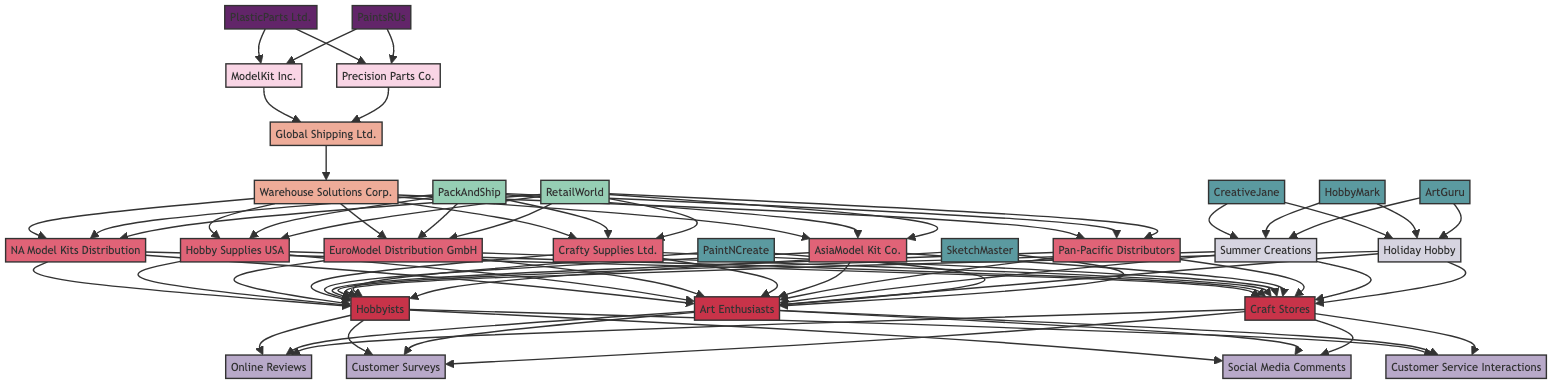What are the two manufacturers listed in the diagram? The diagram shows two manufacturers: ModelKit Inc. and Precision Parts Co.
Answer: ModelKit Inc., Precision Parts Co How many regional distributors are there in total? There are six regional distributors listed: NA Model Kits Distribution, Hobby Supplies USA, EuroModel Distribution GmbH, Crafty Supplies Ltd., AsiaModel Kit Co., and Pan-Pacific Distributors.
Answer: 6 Which influencer has the most followers? Upon reviewing the influencer section, HobbyMark has the highest follower count at 200,000.
Answer: HobbyMark What is the relationship between the influencers and the marketing campaigns? Each influencer is linked to at least one marketing campaign, with CreativeJane, HobbyMark, and ArtGuru connected to the campaigns "Summer Creations" and "Holiday Hobby".
Answer: Influencer-campaign connection How many feedback sources are identified in the customer feedback ecosystem? The diagram shows four feedback sources: Online Reviews, Customer Surveys, Social Media Comments, and Customer Service Interactions.
Answer: 4 Which supplier has high dependency? In the supplier relationships, PlasticParts Ltd. is indicated to have high dependency, while PaintsRUs has medium dependency.
Answer: PlasticParts Ltd Which distributor serves the North American region? The diagram highlights two distributors for North America: NA Model Kits Distribution and Hobby Supplies USA.
Answer: NA Model Kits Distribution, Hobby Supplies USA List the platforms associated with the art influencers. The platforms listed for the influencers are YouTube for PaintNCreate and Instagram for SketchMaster.
Answer: YouTube, Instagram What type of relationship do PackAndShip and RetailWorld have with the distributors? PackAndShip is involved in delivery interactions, while RetailWorld is associated with sales interactions, indicating service-oriented tasks for the distributors.
Answer: Delivery, Sales 